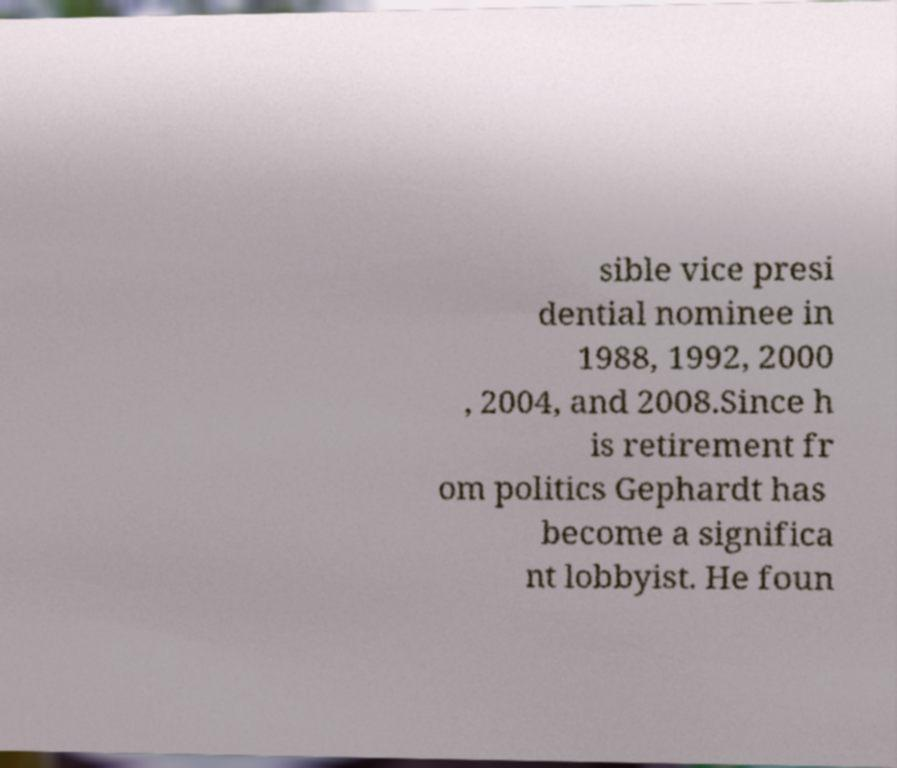Please identify and transcribe the text found in this image. sible vice presi dential nominee in 1988, 1992, 2000 , 2004, and 2008.Since h is retirement fr om politics Gephardt has become a significa nt lobbyist. He foun 